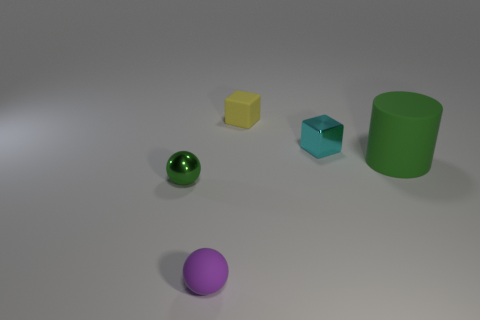Is there anything else that is the same size as the cylinder?
Your answer should be compact. No. Are there any small shiny objects to the left of the cube in front of the tiny matte cube?
Give a very brief answer. Yes. How many green things are right of the small cyan metallic object?
Provide a succinct answer. 1. What is the color of the other tiny object that is the same shape as the purple rubber thing?
Your answer should be very brief. Green. Does the small thing that is in front of the tiny green shiny ball have the same material as the green cylinder that is behind the tiny green thing?
Give a very brief answer. Yes. There is a rubber ball; does it have the same color as the matte object behind the green rubber cylinder?
Give a very brief answer. No. The thing that is both behind the green shiny sphere and in front of the tiny cyan metal object has what shape?
Your answer should be very brief. Cylinder. How many tiny purple balls are there?
Your answer should be very brief. 1. There is a object that is the same color as the cylinder; what is its shape?
Provide a short and direct response. Sphere. What is the size of the green object that is the same shape as the tiny purple thing?
Provide a succinct answer. Small. 